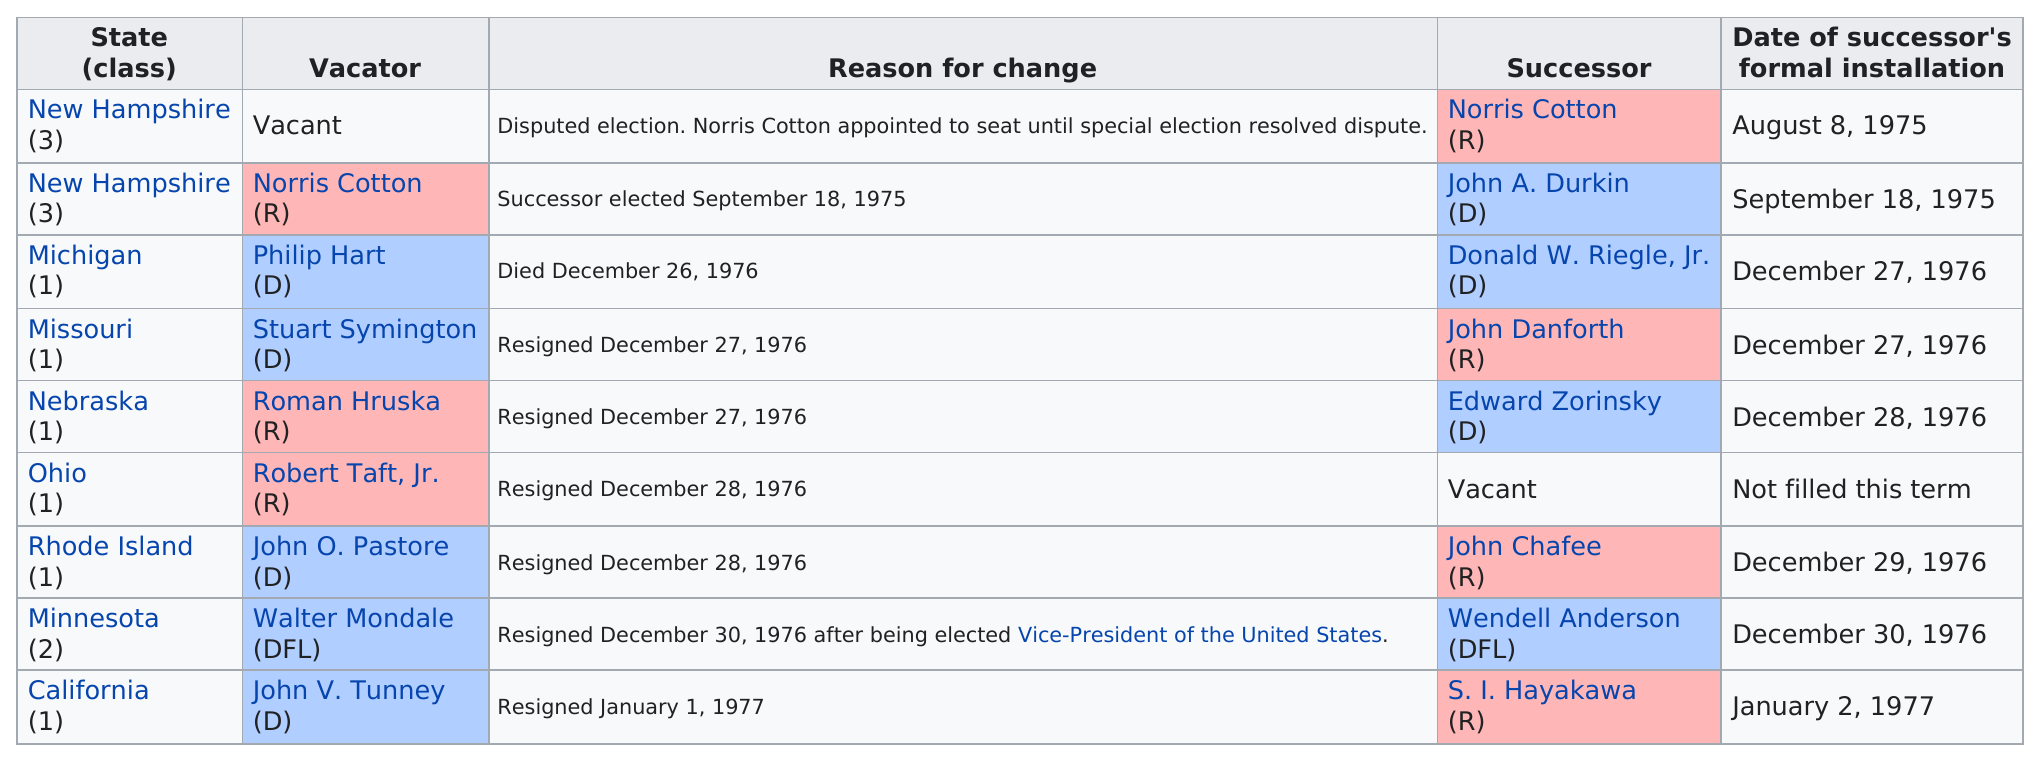Highlight a few significant elements in this photo. According to the data, two individuals from New Hampshire were awarded a seat. Donald W. Riegle, Jr. (D) was the only member of the 94th United States Congress who gained a Senate seat due to the predecessor's death. Walter Mondale, who was elected as the Vice-President of the United States, resigned his senate seat after being sworn into office. During this session, a total of 9 replacements occurred. The Republican political party had the least number of seats in the previous election. 